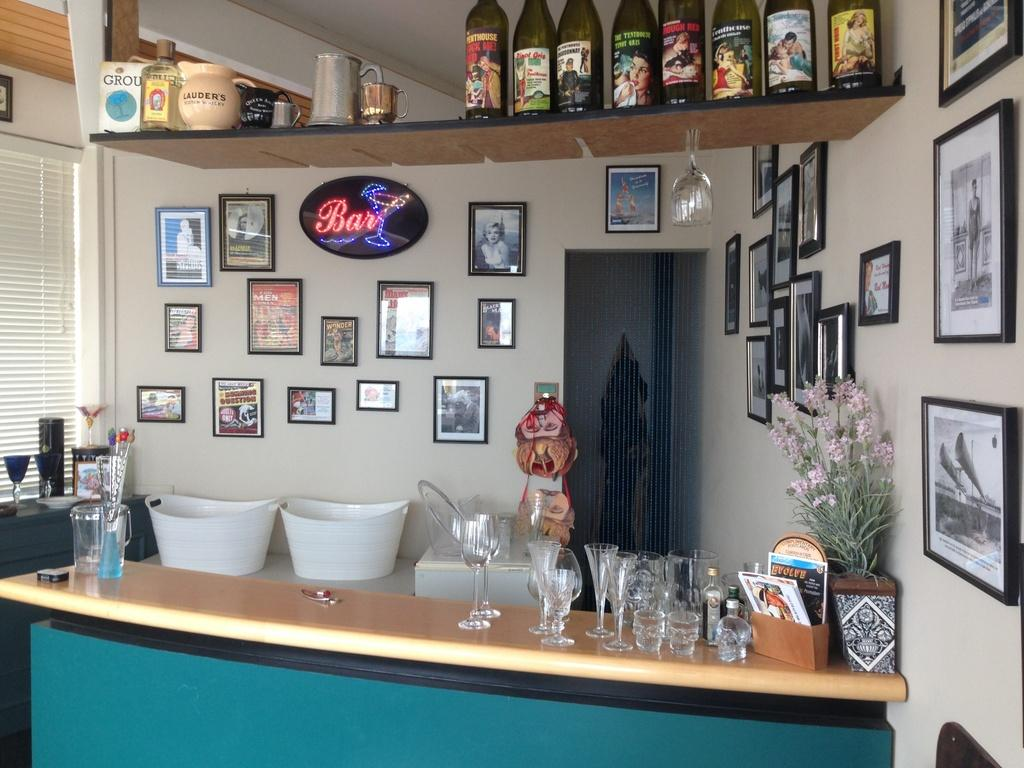<image>
Offer a succinct explanation of the picture presented. A small bar has a light-up sign on the wall that says bar. 